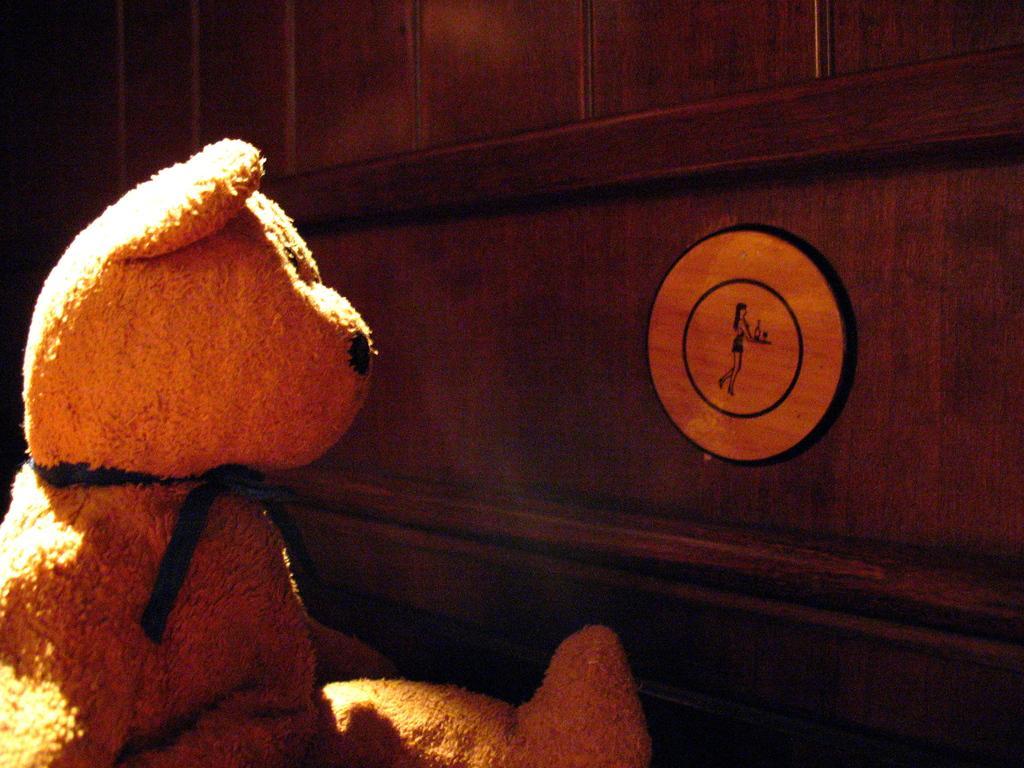Please provide a concise description of this image. On the left there is a teddy bear. In the picture there is a wooden wall. 